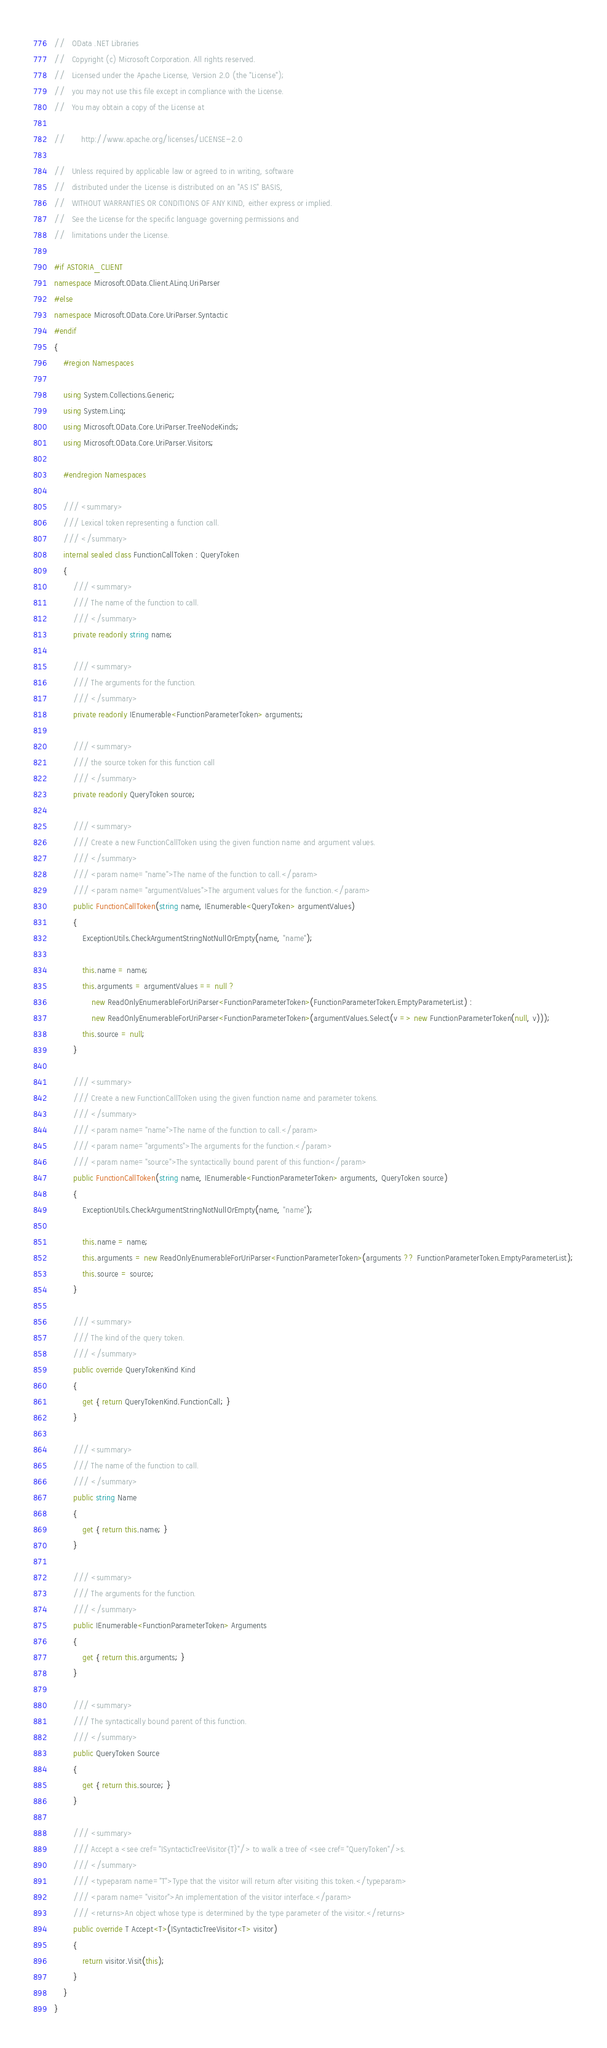Convert code to text. <code><loc_0><loc_0><loc_500><loc_500><_C#_>//   OData .NET Libraries
//   Copyright (c) Microsoft Corporation. All rights reserved.  
//   Licensed under the Apache License, Version 2.0 (the "License");
//   you may not use this file except in compliance with the License.
//   You may obtain a copy of the License at

//       http://www.apache.org/licenses/LICENSE-2.0

//   Unless required by applicable law or agreed to in writing, software
//   distributed under the License is distributed on an "AS IS" BASIS,
//   WITHOUT WARRANTIES OR CONDITIONS OF ANY KIND, either express or implied.
//   See the License for the specific language governing permissions and
//   limitations under the License.

#if ASTORIA_CLIENT
namespace Microsoft.OData.Client.ALinq.UriParser
#else
namespace Microsoft.OData.Core.UriParser.Syntactic
#endif
{
    #region Namespaces

    using System.Collections.Generic;
    using System.Linq;
    using Microsoft.OData.Core.UriParser.TreeNodeKinds;
    using Microsoft.OData.Core.UriParser.Visitors;

    #endregion Namespaces

    /// <summary>
    /// Lexical token representing a function call.
    /// </summary>
    internal sealed class FunctionCallToken : QueryToken
    {
        /// <summary>
        /// The name of the function to call.
        /// </summary>
        private readonly string name;

        /// <summary>
        /// The arguments for the function.
        /// </summary>
        private readonly IEnumerable<FunctionParameterToken> arguments;

        /// <summary>
        /// the source token for this function call
        /// </summary>
        private readonly QueryToken source;

        /// <summary>
        /// Create a new FunctionCallToken using the given function name and argument values.
        /// </summary>
        /// <param name="name">The name of the function to call.</param>
        /// <param name="argumentValues">The argument values for the function.</param>
        public FunctionCallToken(string name, IEnumerable<QueryToken> argumentValues)
        {
            ExceptionUtils.CheckArgumentStringNotNullOrEmpty(name, "name");

            this.name = name;
            this.arguments = argumentValues == null ? 
                new ReadOnlyEnumerableForUriParser<FunctionParameterToken>(FunctionParameterToken.EmptyParameterList) : 
                new ReadOnlyEnumerableForUriParser<FunctionParameterToken>(argumentValues.Select(v => new FunctionParameterToken(null, v)));
            this.source = null;
        }

        /// <summary>
        /// Create a new FunctionCallToken using the given function name and parameter tokens.
        /// </summary>
        /// <param name="name">The name of the function to call.</param>
        /// <param name="arguments">The arguments for the function.</param>
        /// <param name="source">The syntactically bound parent of this function</param>
        public FunctionCallToken(string name, IEnumerable<FunctionParameterToken> arguments, QueryToken source)
        {
            ExceptionUtils.CheckArgumentStringNotNullOrEmpty(name, "name");

            this.name = name;
            this.arguments = new ReadOnlyEnumerableForUriParser<FunctionParameterToken>(arguments ?? FunctionParameterToken.EmptyParameterList);
            this.source = source;
        }

        /// <summary>
        /// The kind of the query token.
        /// </summary>
        public override QueryTokenKind Kind
        {
            get { return QueryTokenKind.FunctionCall; }
        }

        /// <summary>
        /// The name of the function to call.
        /// </summary>
        public string Name
        {
            get { return this.name; }
        }

        /// <summary>
        /// The arguments for the function.
        /// </summary>
        public IEnumerable<FunctionParameterToken> Arguments
        {
            get { return this.arguments; }
        }

        /// <summary>
        /// The syntactically bound parent of this function.
        /// </summary>
        public QueryToken Source
        {
            get { return this.source; }
        }

        /// <summary>
        /// Accept a <see cref="ISyntacticTreeVisitor{T}"/> to walk a tree of <see cref="QueryToken"/>s.
        /// </summary>
        /// <typeparam name="T">Type that the visitor will return after visiting this token.</typeparam>
        /// <param name="visitor">An implementation of the visitor interface.</param>
        /// <returns>An object whose type is determined by the type parameter of the visitor.</returns>
        public override T Accept<T>(ISyntacticTreeVisitor<T> visitor)
        {
            return visitor.Visit(this);
        }
    }
}
</code> 